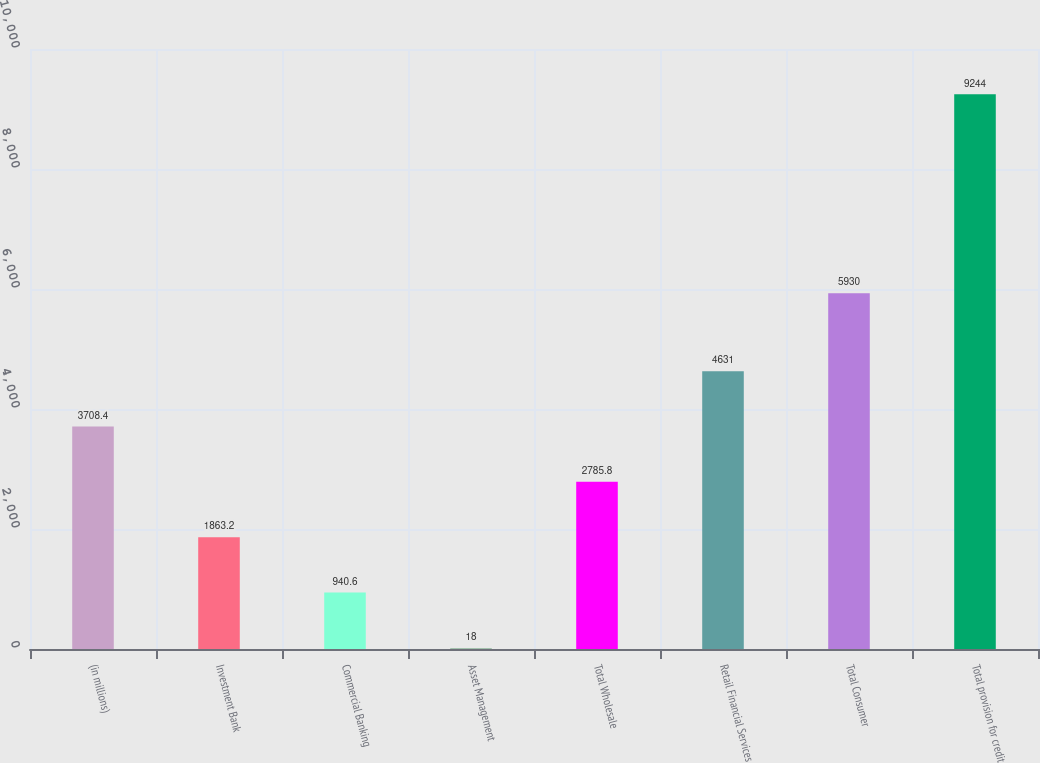Convert chart. <chart><loc_0><loc_0><loc_500><loc_500><bar_chart><fcel>(in millions)<fcel>Investment Bank<fcel>Commercial Banking<fcel>Asset Management<fcel>Total Wholesale<fcel>Retail Financial Services<fcel>Total Consumer<fcel>Total provision for credit<nl><fcel>3708.4<fcel>1863.2<fcel>940.6<fcel>18<fcel>2785.8<fcel>4631<fcel>5930<fcel>9244<nl></chart> 